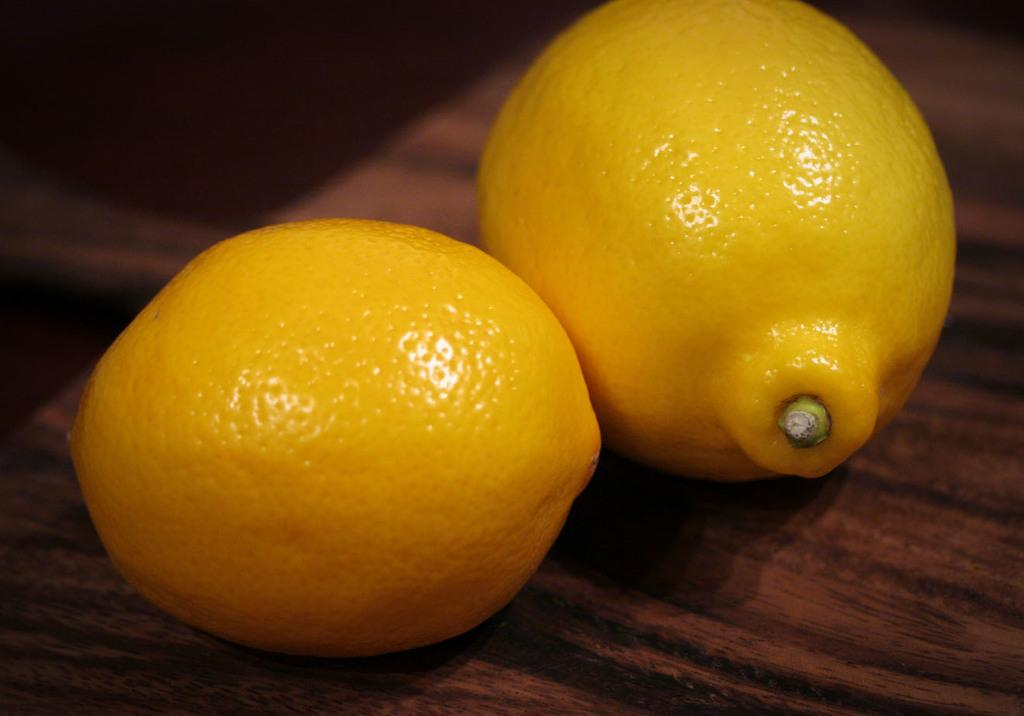What is the main object in the center of the image? There is a table in the center of the image. What items are placed on the table? There are two oranges on the table. What is the color of the oranges? The oranges are in yellow color. What type of scarf is draped over the oranges on the table? There is no scarf present in the image; it only features a table with two yellow oranges. 